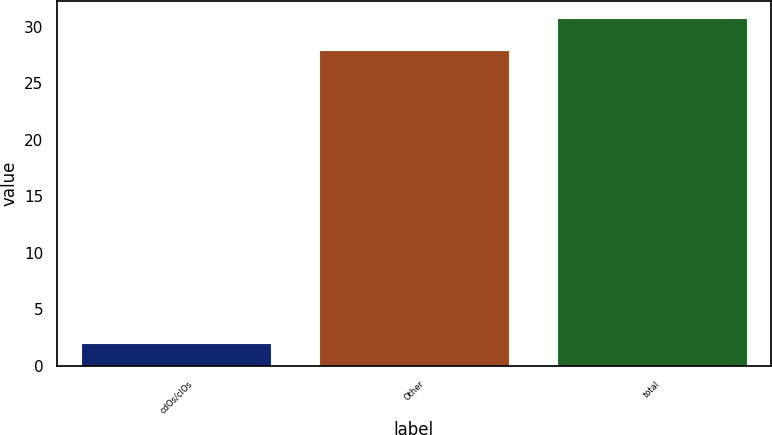Convert chart. <chart><loc_0><loc_0><loc_500><loc_500><bar_chart><fcel>cdOs/clOs<fcel>Other<fcel>total<nl><fcel>2<fcel>28<fcel>30.8<nl></chart> 